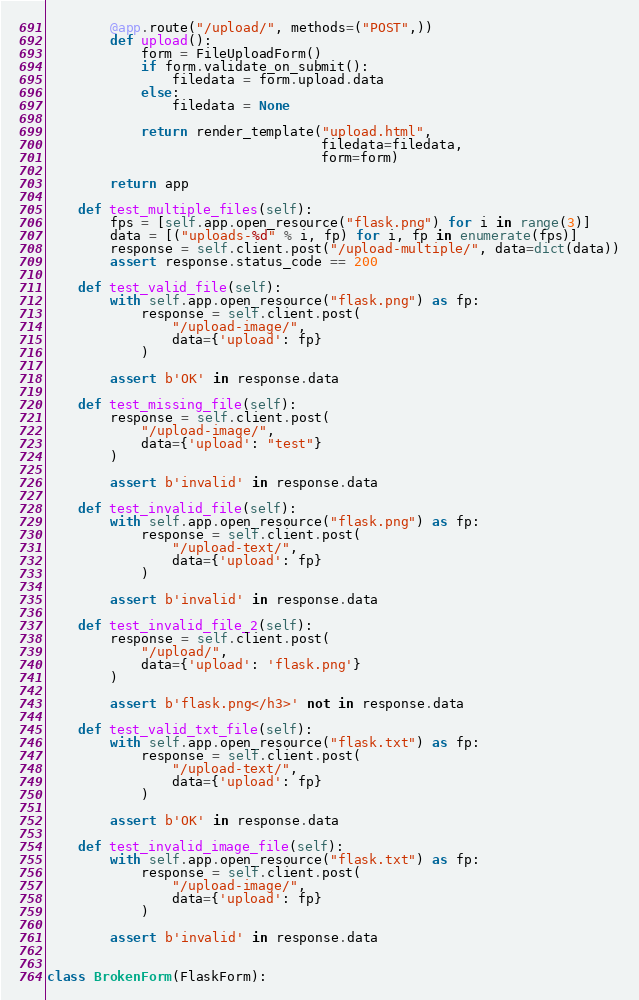<code> <loc_0><loc_0><loc_500><loc_500><_Python_>
        @app.route("/upload/", methods=("POST",))
        def upload():
            form = FileUploadForm()
            if form.validate_on_submit():
                filedata = form.upload.data
            else:
                filedata = None

            return render_template("upload.html",
                                   filedata=filedata,
                                   form=form)

        return app

    def test_multiple_files(self):
        fps = [self.app.open_resource("flask.png") for i in range(3)]
        data = [("uploads-%d" % i, fp) for i, fp in enumerate(fps)]
        response = self.client.post("/upload-multiple/", data=dict(data))
        assert response.status_code == 200

    def test_valid_file(self):
        with self.app.open_resource("flask.png") as fp:
            response = self.client.post(
                "/upload-image/",
                data={'upload': fp}
            )

        assert b'OK' in response.data

    def test_missing_file(self):
        response = self.client.post(
            "/upload-image/",
            data={'upload': "test"}
        )

        assert b'invalid' in response.data

    def test_invalid_file(self):
        with self.app.open_resource("flask.png") as fp:
            response = self.client.post(
                "/upload-text/",
                data={'upload': fp}
            )

        assert b'invalid' in response.data

    def test_invalid_file_2(self):
        response = self.client.post(
            "/upload/",
            data={'upload': 'flask.png'}
        )

        assert b'flask.png</h3>' not in response.data

    def test_valid_txt_file(self):
        with self.app.open_resource("flask.txt") as fp:
            response = self.client.post(
                "/upload-text/",
                data={'upload': fp}
            )

        assert b'OK' in response.data

    def test_invalid_image_file(self):
        with self.app.open_resource("flask.txt") as fp:
            response = self.client.post(
                "/upload-image/",
                data={'upload': fp}
            )

        assert b'invalid' in response.data


class BrokenForm(FlaskForm):</code> 